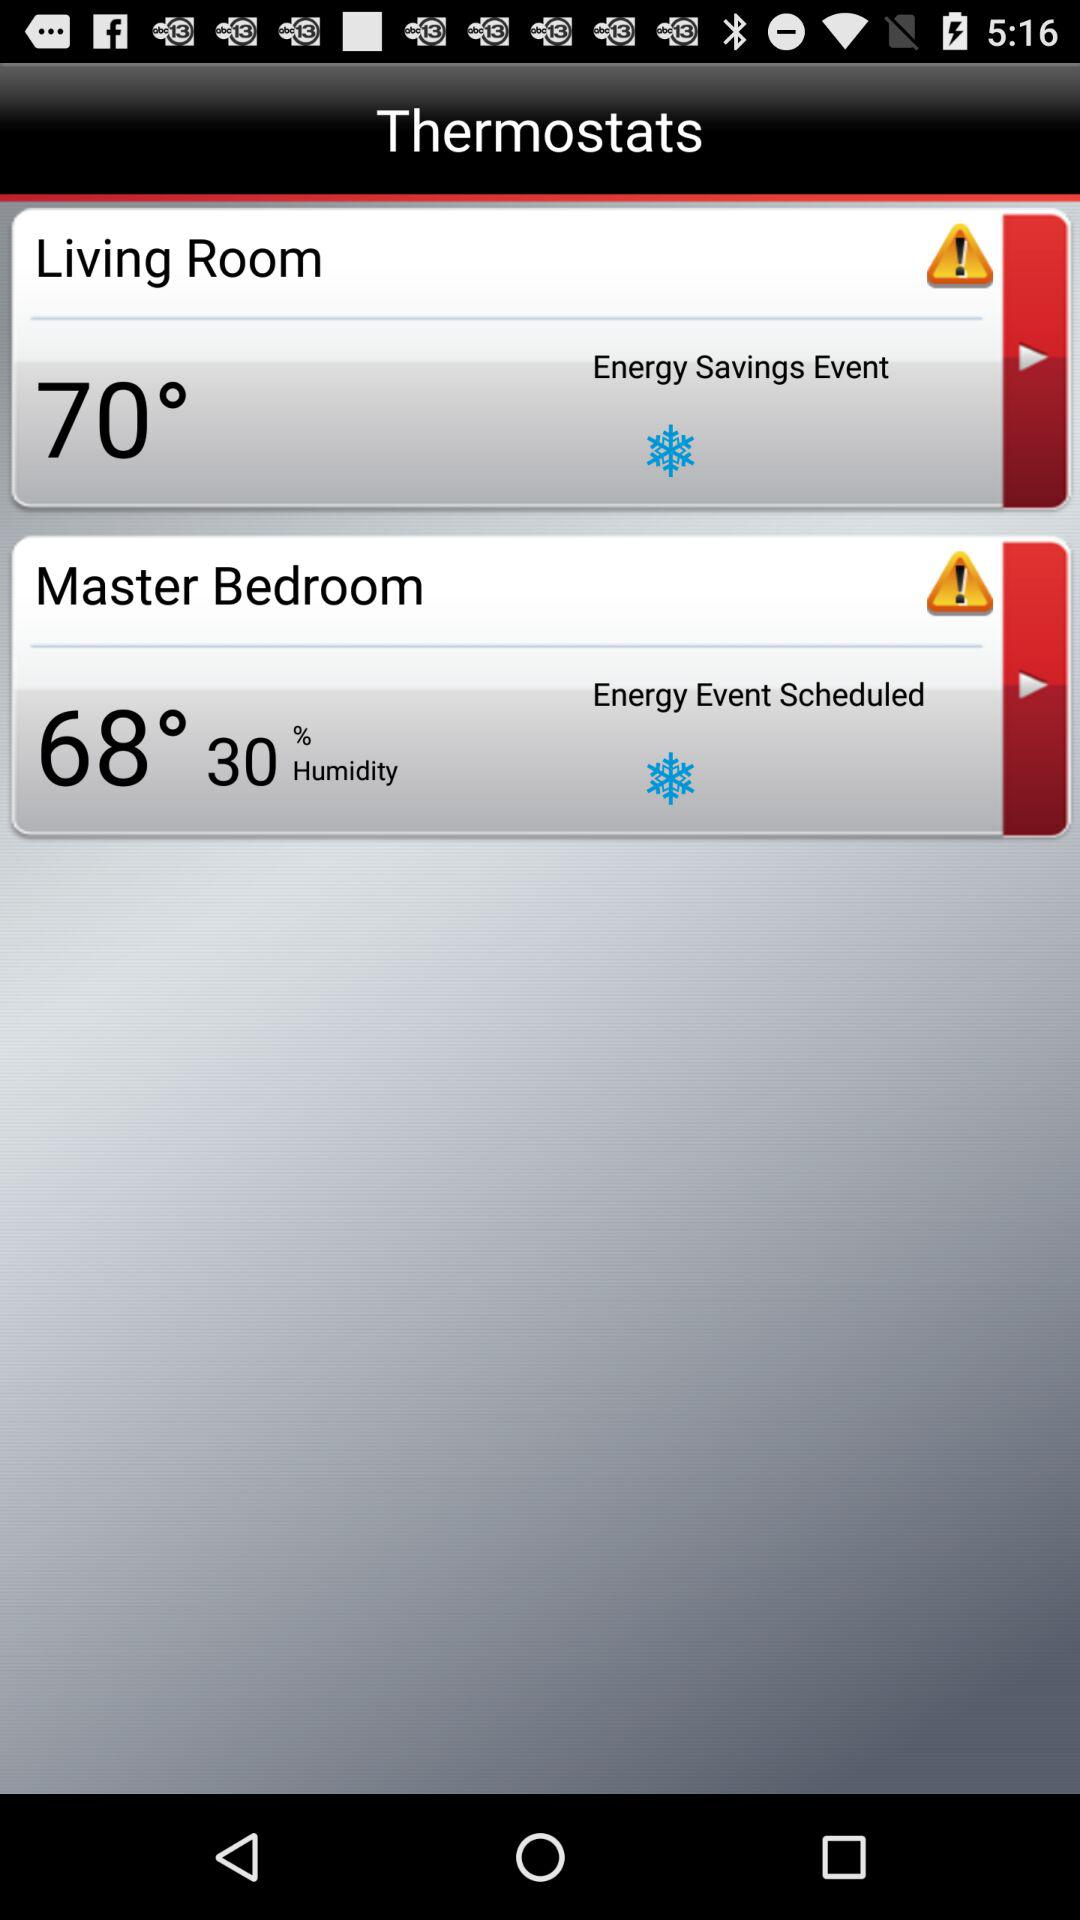What is the temperature of the living room? The temperature is 70°. 